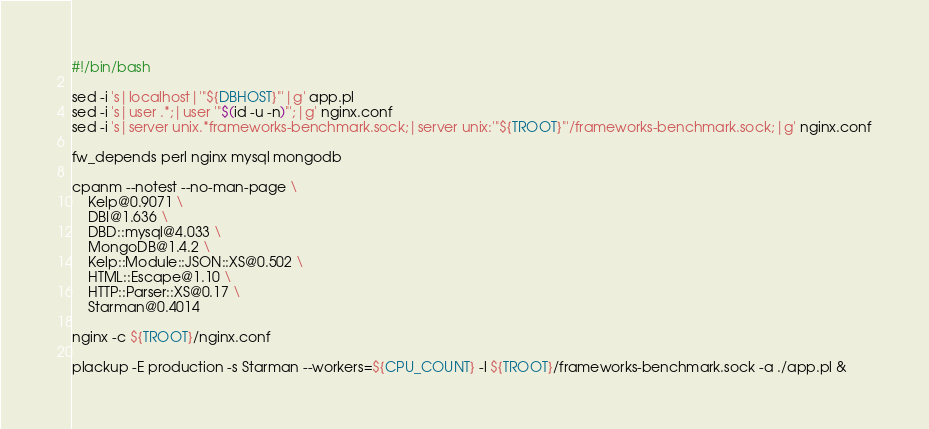<code> <loc_0><loc_0><loc_500><loc_500><_Bash_>#!/bin/bash

sed -i 's|localhost|'"${DBHOST}"'|g' app.pl
sed -i 's|user .*;|user '"$(id -u -n)"';|g' nginx.conf
sed -i 's|server unix.*frameworks-benchmark.sock;|server unix:'"${TROOT}"'/frameworks-benchmark.sock;|g' nginx.conf

fw_depends perl nginx mysql mongodb

cpanm --notest --no-man-page \
    Kelp@0.9071 \
    DBI@1.636 \
    DBD::mysql@4.033 \
    MongoDB@1.4.2 \
    Kelp::Module::JSON::XS@0.502 \
    HTML::Escape@1.10 \
    HTTP::Parser::XS@0.17 \
    Starman@0.4014

nginx -c ${TROOT}/nginx.conf

plackup -E production -s Starman --workers=${CPU_COUNT} -l ${TROOT}/frameworks-benchmark.sock -a ./app.pl &
</code> 